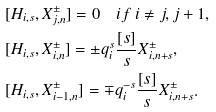<formula> <loc_0><loc_0><loc_500><loc_500>& [ H _ { i , s } , X _ { j , n } ^ { \pm } ] = 0 \quad i f \ i \neq j , j + 1 , \\ & [ H _ { i , s } , X _ { i , n } ^ { \pm } ] = \pm q _ { i } ^ { s } \frac { [ s ] } { s } X _ { i , n + s } ^ { \pm } , \\ & [ H _ { i , s } , X _ { i - 1 , n } ^ { \pm } ] = \mp q _ { i } ^ { - s } \frac { [ s ] } { s } X _ { i , n + s } ^ { \pm } .</formula> 